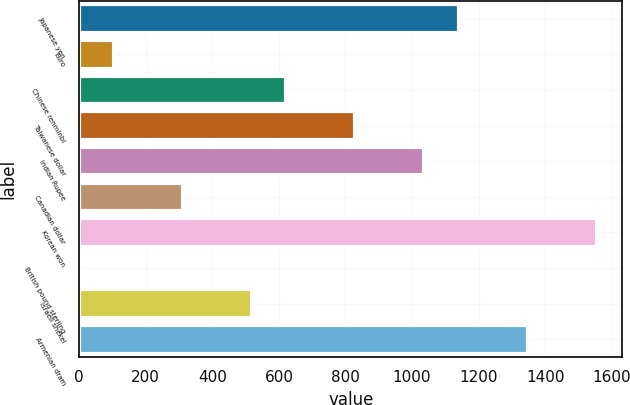Convert chart. <chart><loc_0><loc_0><loc_500><loc_500><bar_chart><fcel>Japanese yen<fcel>Euro<fcel>Chinese renminbi<fcel>Taiwanese dollar<fcel>Indian Rupee<fcel>Canadian dollar<fcel>Korean won<fcel>British pound sterling<fcel>Israeli shekel<fcel>Armenian dram<nl><fcel>1139.99<fcel>104.19<fcel>622.09<fcel>829.25<fcel>1036.41<fcel>311.35<fcel>1554.31<fcel>0.61<fcel>518.51<fcel>1347.15<nl></chart> 